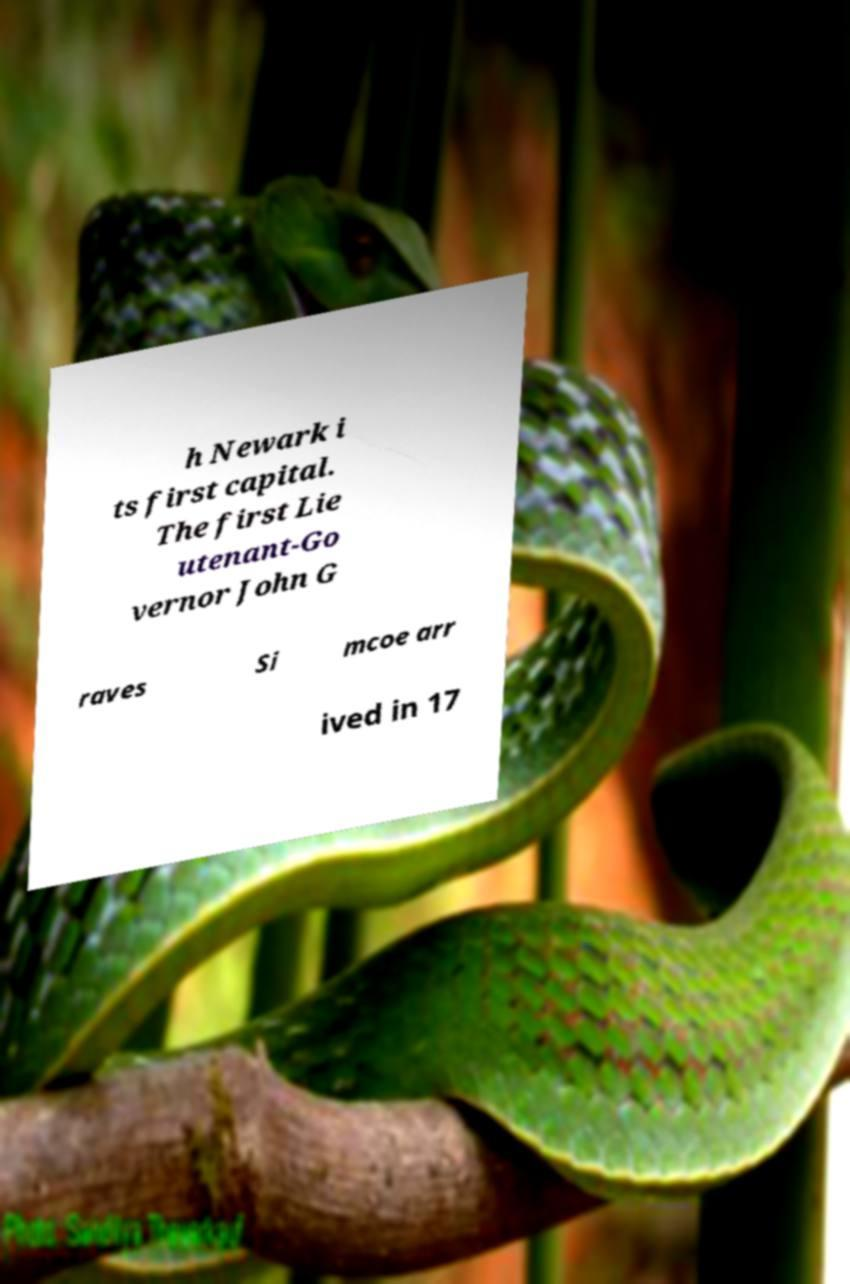Can you accurately transcribe the text from the provided image for me? h Newark i ts first capital. The first Lie utenant-Go vernor John G raves Si mcoe arr ived in 17 